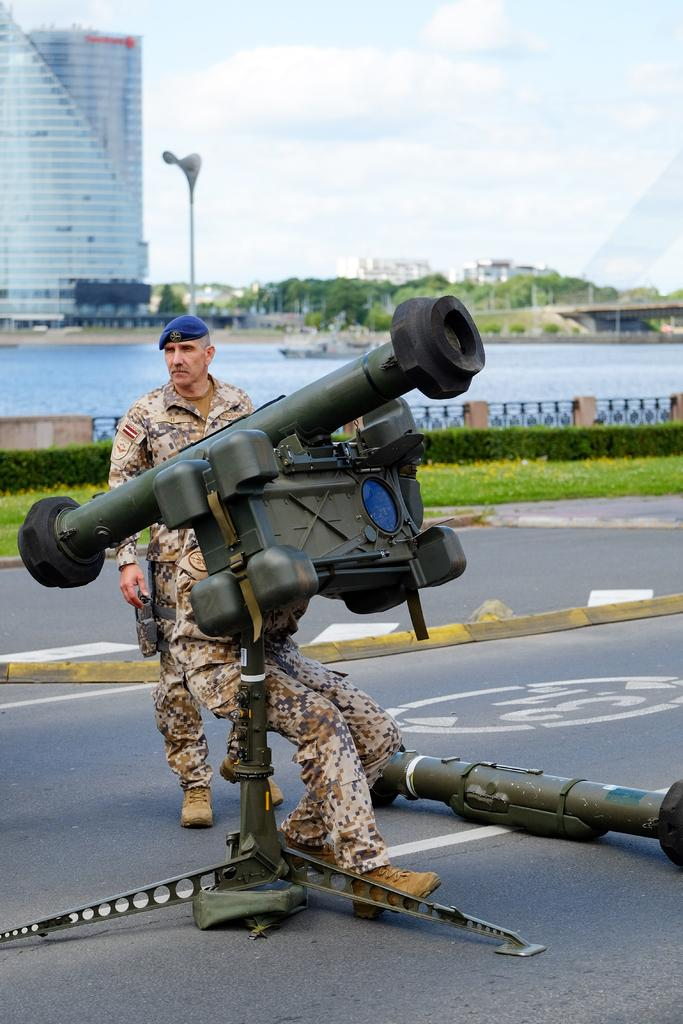What is the person in the image holding? The person is holding a weapon in the image. Where is the person standing? The person is standing on the road. What can be seen in the background of the image? In the background of the image, there is water, a ship, buildings, trees, a bridge, and the sky. What is the condition of the sky in the image? The sky is visible in the background of the image, and there are clouds present. Can you tell me how many tigers are swimming in the water in the image? There are no tigers present in the image, and therefore no tigers can be seen swimming in the water. What type of sink is visible in the image? There is no sink present in the image. 